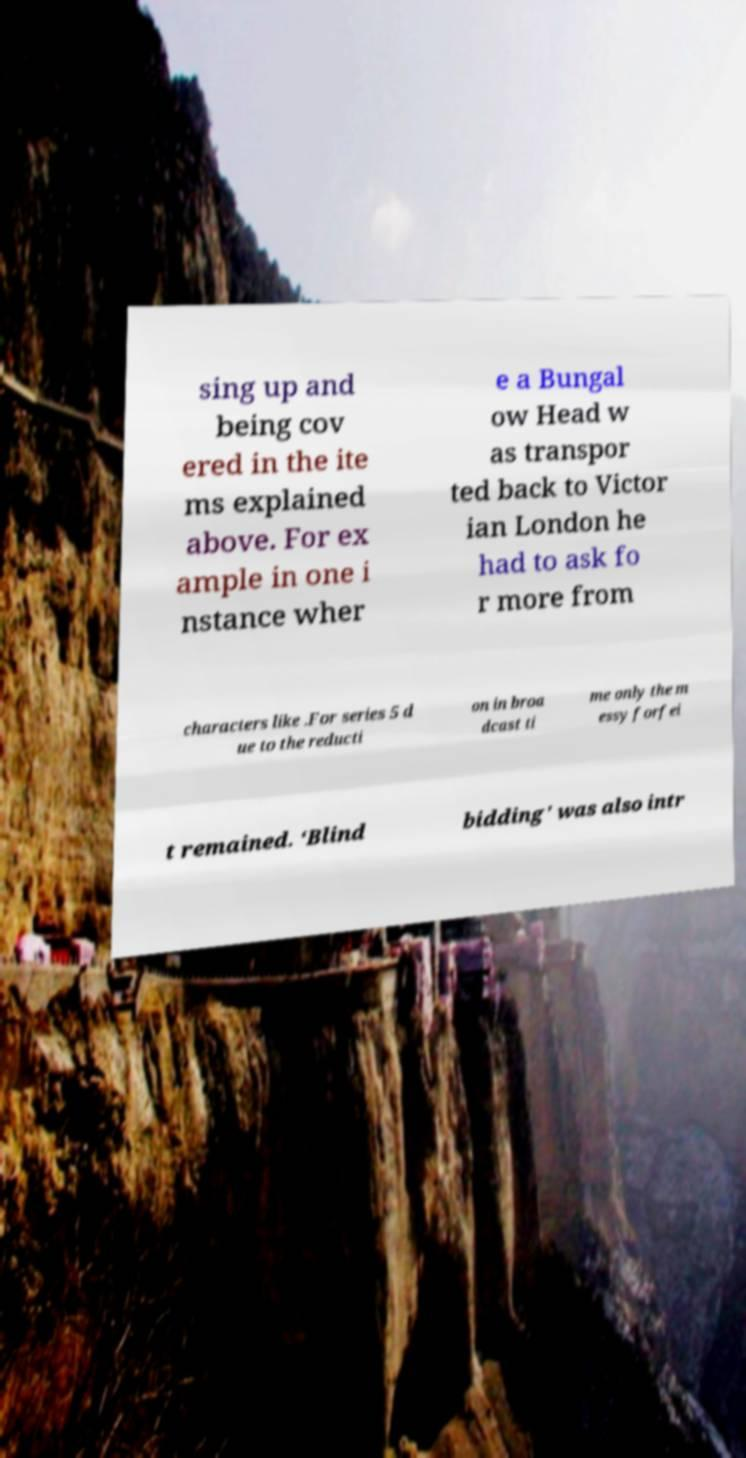Can you accurately transcribe the text from the provided image for me? sing up and being cov ered in the ite ms explained above. For ex ample in one i nstance wher e a Bungal ow Head w as transpor ted back to Victor ian London he had to ask fo r more from characters like .For series 5 d ue to the reducti on in broa dcast ti me only the m essy forfei t remained. ‘Blind bidding' was also intr 